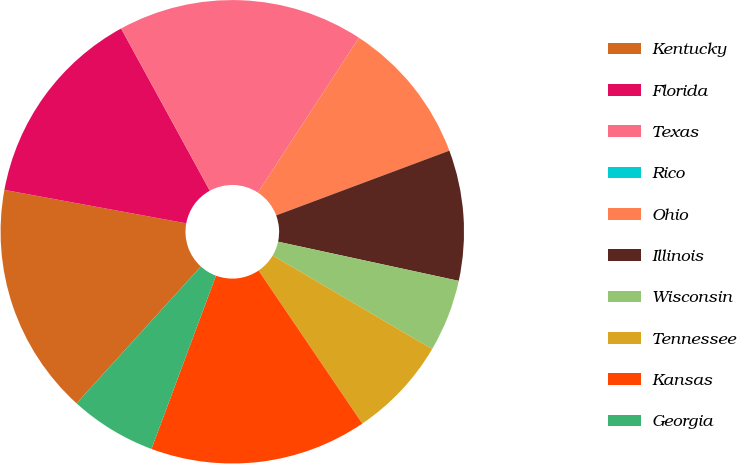Convert chart to OTSL. <chart><loc_0><loc_0><loc_500><loc_500><pie_chart><fcel>Kentucky<fcel>Florida<fcel>Texas<fcel>Rico<fcel>Ohio<fcel>Illinois<fcel>Wisconsin<fcel>Tennessee<fcel>Kansas<fcel>Georgia<nl><fcel>16.16%<fcel>14.14%<fcel>17.17%<fcel>0.0%<fcel>10.1%<fcel>9.09%<fcel>5.05%<fcel>7.07%<fcel>15.15%<fcel>6.06%<nl></chart> 